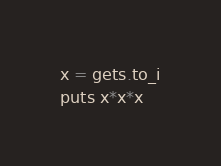<code> <loc_0><loc_0><loc_500><loc_500><_Ruby_>x = gets.to_i
puts x*x*x</code> 